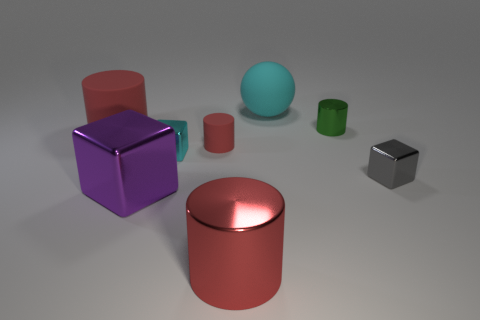What material is the other tiny thing that is the same shape as the small red rubber thing? metal 